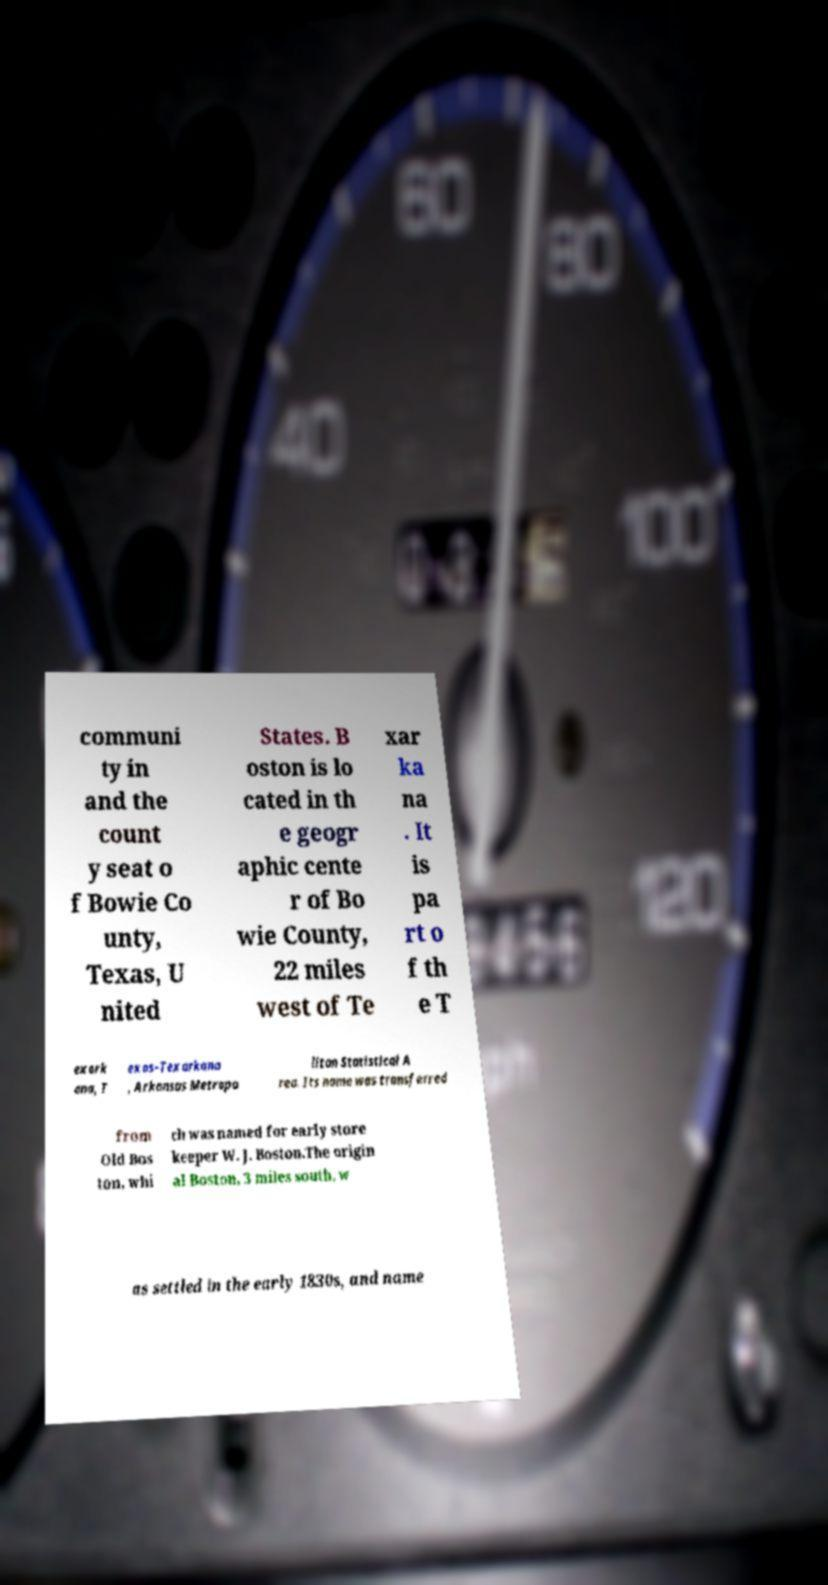What messages or text are displayed in this image? I need them in a readable, typed format. communi ty in and the count y seat o f Bowie Co unty, Texas, U nited States. B oston is lo cated in th e geogr aphic cente r of Bo wie County, 22 miles west of Te xar ka na . It is pa rt o f th e T exark ana, T exas–Texarkana , Arkansas Metropo litan Statistical A rea. Its name was transferred from Old Bos ton, whi ch was named for early store keeper W. J. Boston.The origin al Boston, 3 miles south, w as settled in the early 1830s, and name 